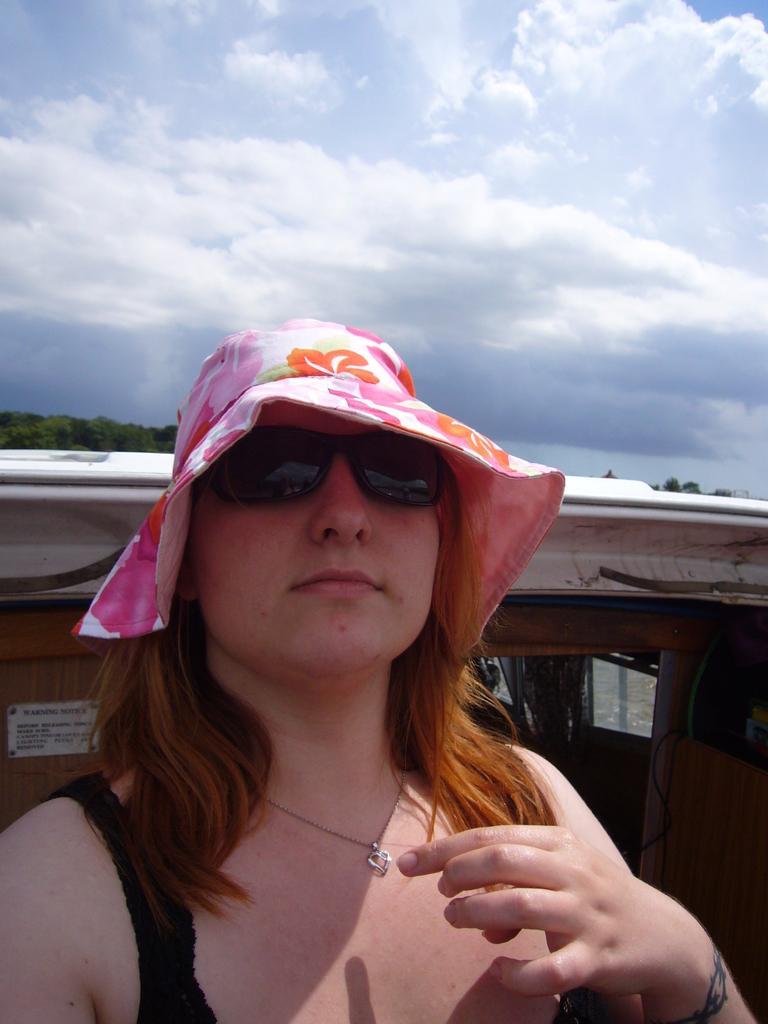Can you describe this image briefly? In this image I can see a woman wearing a pink color cap and wearing spectacles and back side of I can see vehicle and at the top I can see the sky and clouds. 